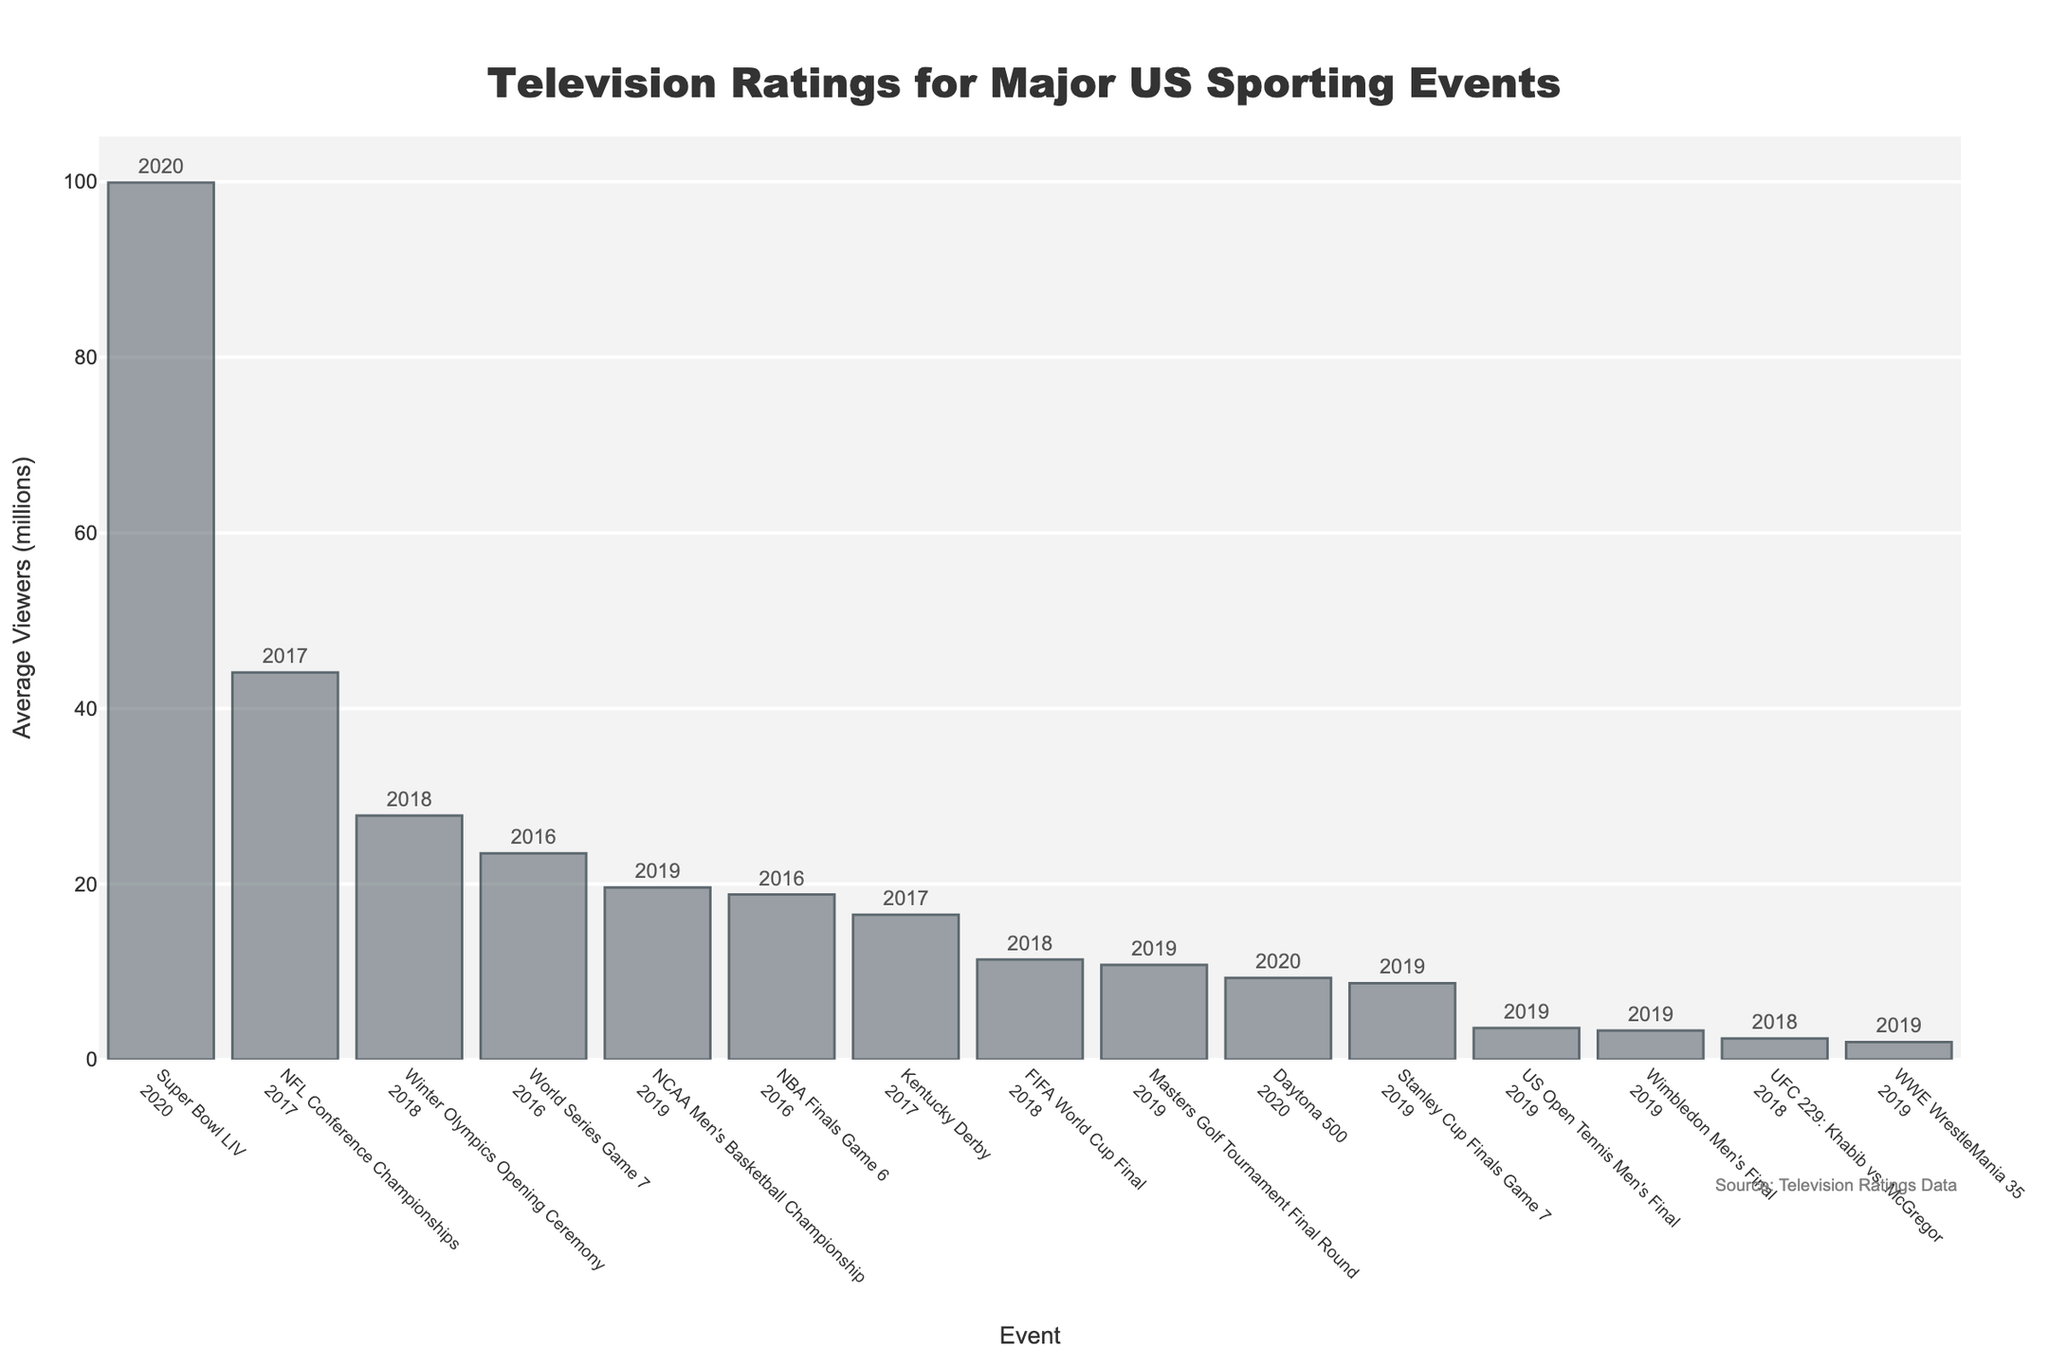What event had the highest average viewership? Look for the tallest bar in the chart, which represents the event with the highest average viewers. The Super Bowl LIV is at the top with the highest bar.
Answer: Super Bowl LIV Which event had the lowest average viewership? Locate the shortest bar in the chart, representing the event with the lowest average viewers. WWE WrestleMania 35 has the shortest bar.
Answer: WWE WrestleMania 35 How does the viewership of the Super Bowl LIV (2020) compare to the average of the NCAA Men's Basketball Championship (2019) and NBA Finals Game 6 (2016)? Find the average of the viewership for the NCAA Men's Basketball Championship and NBA Finals Game 6, then compare it to the Super Bowl LIV. The average is (19.6 + 18.8) / 2 = 19.2. Compare this to Super Bowl LIV's 99.9 million viewers.
Answer: Super Bowl LIV is much higher What is the sum of the average viewers for the events in 2019? Identify all bars labeled with "2019" and sum their average viewership values. The events are NCAA Men's Basketball Championship (19.6), Stanley Cup Finals Game 7 (8.7), US Open Tennis Men's Final (3.6), Wimbledon Men's Final (3.3), WWE WrestleMania 35 (2.0), and Masters Golf Tournament Final Round (10.8). Summing these gives 48.0
Answer: 48.0 Which event in 2018 had higher viewership: the Winter Olympics Opening Ceremony or the FIFA World Cup Final? Compare the bar heights of the Winter Olympics Opening Ceremony and the FIFA World Cup Final in 2018 in terms of viewership. The Winter Olympics Opening Ceremony's bar is higher at 27.8 million viewers compared to the FIFA World Cup Final's 11.4 million viewers.
Answer: Winter Olympics Opening Ceremony What is the average viewership of the three events from 2016 on the chart? Identify the three events from 2016: NBA Finals Game 6 (18.8), and World Series Game 7 (23.5). Calculate the average: (18.8 + 23.5) / 2 = 21.15
Answer: 21.15 How many events had an average viewership of over 20 million? Count the number of bars that are taller than the 20 million mark in the chart. The events are Super Bowl LIV, Winter Olympics Opening Ceremony, World Series Game 7, and NFL Conference Championships, totaling 4.
Answer: 4 